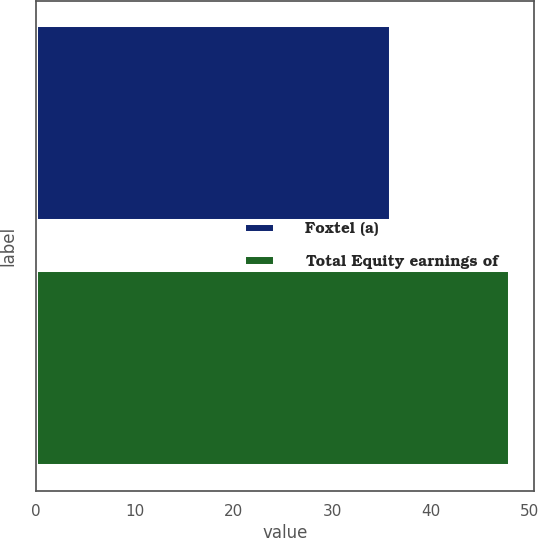<chart> <loc_0><loc_0><loc_500><loc_500><bar_chart><fcel>Foxtel (a)<fcel>Total Equity earnings of<nl><fcel>36<fcel>48<nl></chart> 